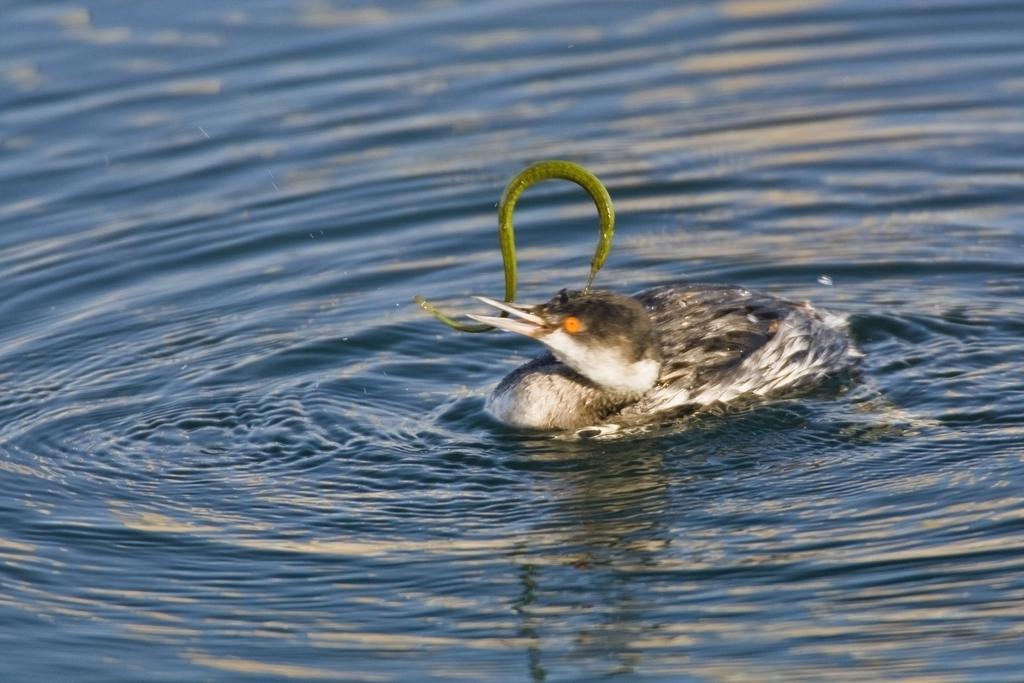How would you summarize this image in a sentence or two? In this picture there is hooded merganser in the center of the image, on the water and there is water around the area of the image. 